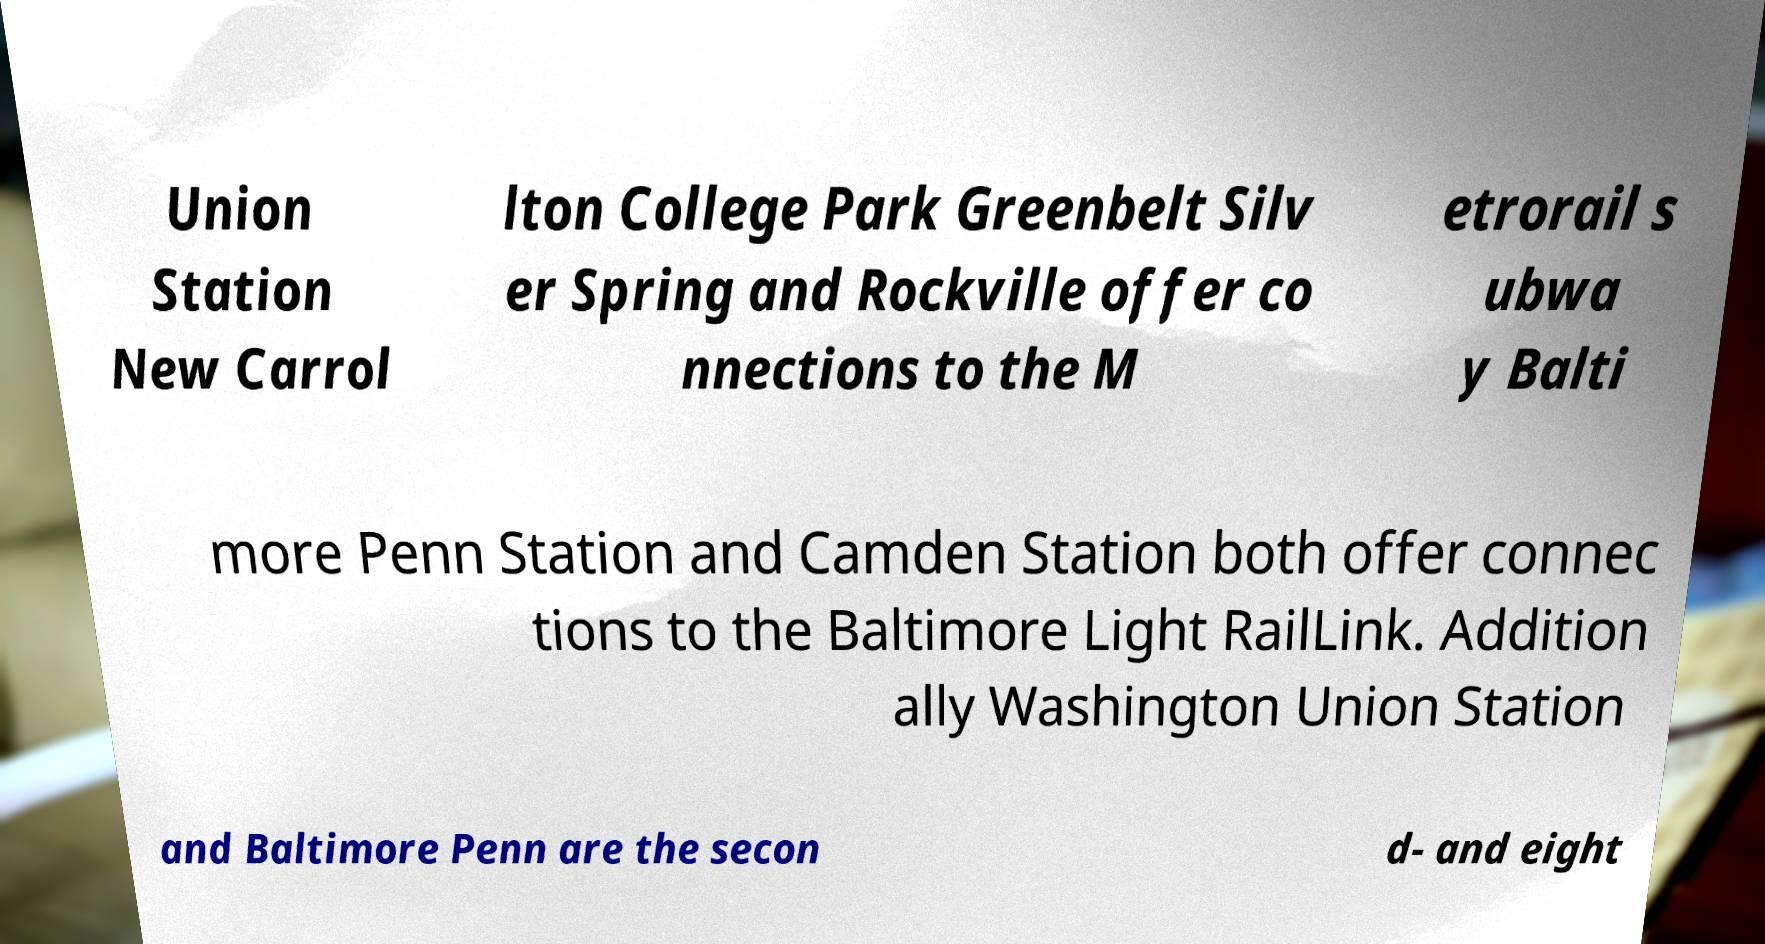For documentation purposes, I need the text within this image transcribed. Could you provide that? Union Station New Carrol lton College Park Greenbelt Silv er Spring and Rockville offer co nnections to the M etrorail s ubwa y Balti more Penn Station and Camden Station both offer connec tions to the Baltimore Light RailLink. Addition ally Washington Union Station and Baltimore Penn are the secon d- and eight 